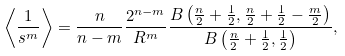<formula> <loc_0><loc_0><loc_500><loc_500>\left \langle \frac { 1 } { s ^ { m } } \right \rangle = \frac { n } { n - m } \frac { 2 ^ { n - m } } { R ^ { m } } \frac { B \left ( \frac { n } { 2 } + \frac { 1 } { 2 } , \frac { n } { 2 } + \frac { 1 } { 2 } - \frac { m } { 2 } \right ) } { B \left ( \frac { n } { 2 } + \frac { 1 } { 2 } , \frac { 1 } { 2 } \right ) } ,</formula> 